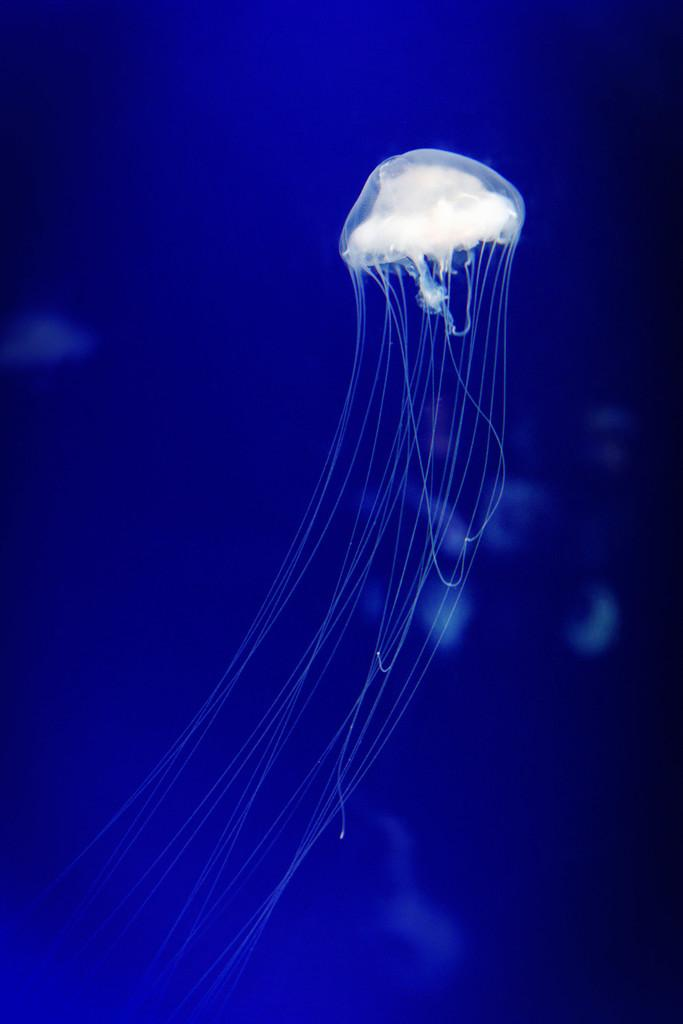What is the main subject of the image? There is a white-colored jellyfish in the image. What color is the background of the image? The background of the image is blue. Are there any other white-colored objects in the image? Yes, there are white-colored things in the background of the image. What type of bushes can be seen in the image? There are no bushes present in the image. Can you tell me how many screws are visible in the image? There are no screws visible in the image. 